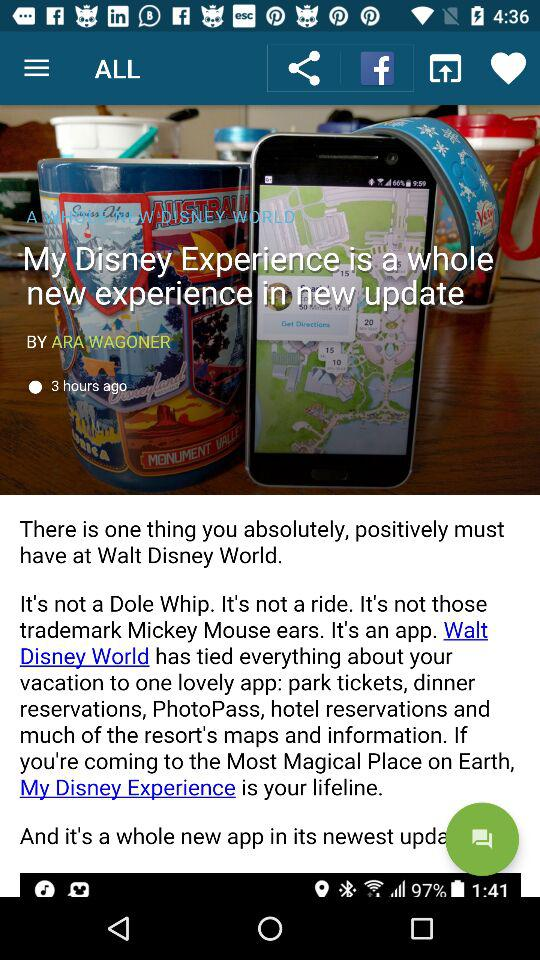How many hours ago was the article published?
Answer the question using a single word or phrase. 3 